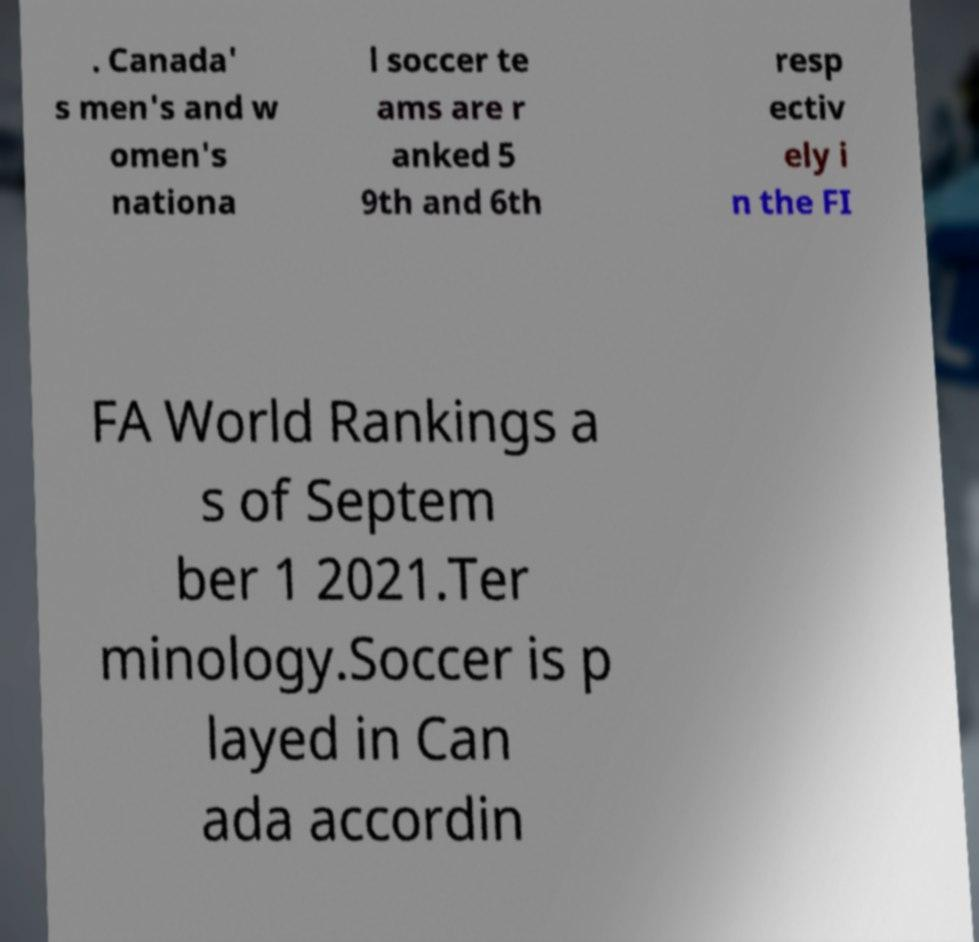Can you accurately transcribe the text from the provided image for me? . Canada' s men's and w omen's nationa l soccer te ams are r anked 5 9th and 6th resp ectiv ely i n the FI FA World Rankings a s of Septem ber 1 2021.Ter minology.Soccer is p layed in Can ada accordin 